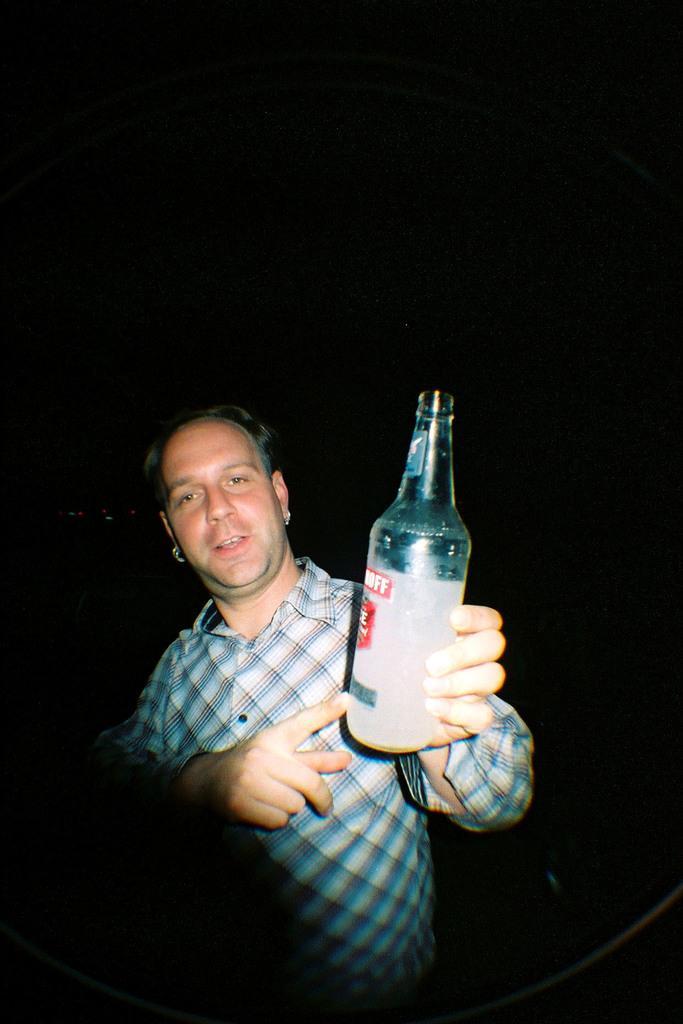Please provide a concise description of this image. In this picture there is a man who is holding a bottle in his hand. 